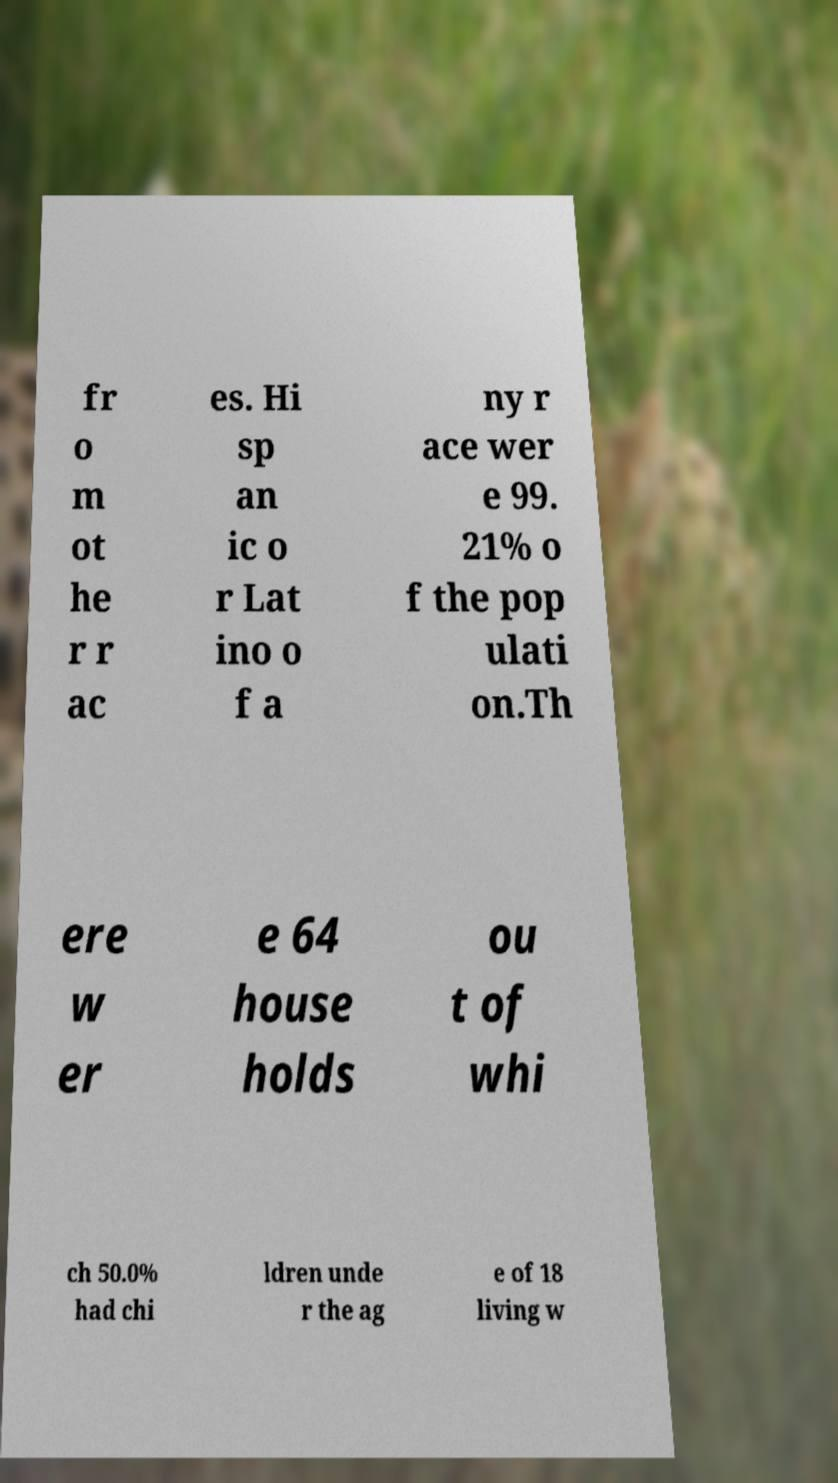I need the written content from this picture converted into text. Can you do that? fr o m ot he r r ac es. Hi sp an ic o r Lat ino o f a ny r ace wer e 99. 21% o f the pop ulati on.Th ere w er e 64 house holds ou t of whi ch 50.0% had chi ldren unde r the ag e of 18 living w 